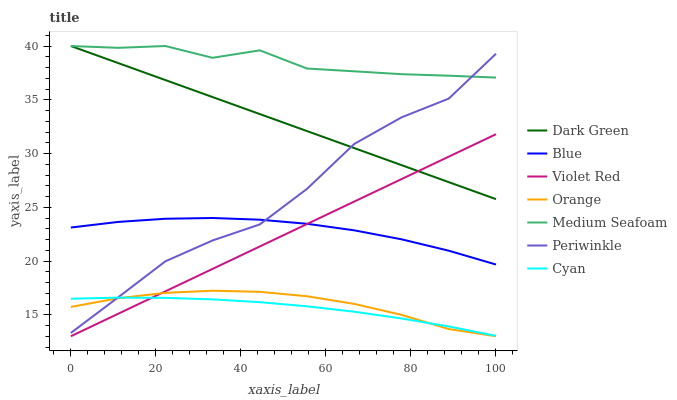Does Cyan have the minimum area under the curve?
Answer yes or no. Yes. Does Medium Seafoam have the maximum area under the curve?
Answer yes or no. Yes. Does Violet Red have the minimum area under the curve?
Answer yes or no. No. Does Violet Red have the maximum area under the curve?
Answer yes or no. No. Is Violet Red the smoothest?
Answer yes or no. Yes. Is Periwinkle the roughest?
Answer yes or no. Yes. Is Periwinkle the smoothest?
Answer yes or no. No. Is Violet Red the roughest?
Answer yes or no. No. Does Periwinkle have the lowest value?
Answer yes or no. No. Does Violet Red have the highest value?
Answer yes or no. No. Is Blue less than Medium Seafoam?
Answer yes or no. Yes. Is Blue greater than Orange?
Answer yes or no. Yes. Does Blue intersect Medium Seafoam?
Answer yes or no. No. 